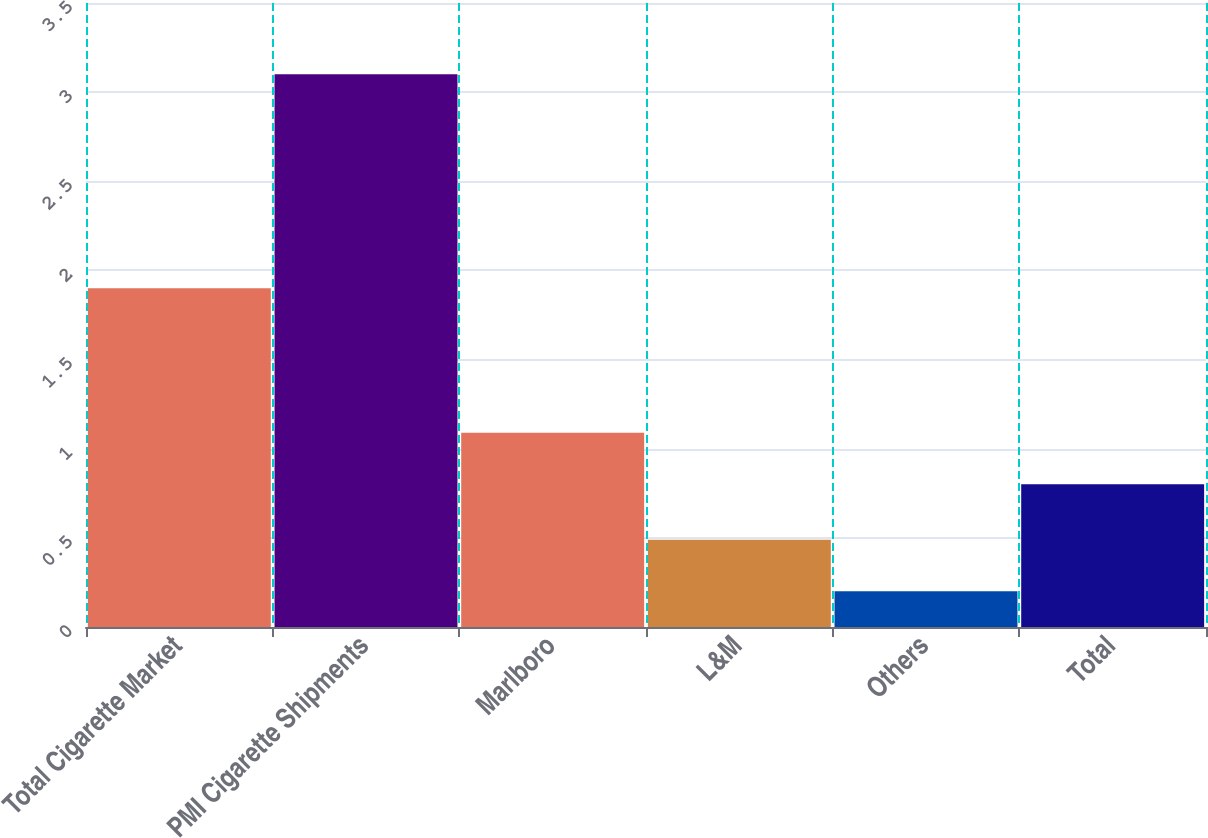Convert chart to OTSL. <chart><loc_0><loc_0><loc_500><loc_500><bar_chart><fcel>Total Cigarette Market<fcel>PMI Cigarette Shipments<fcel>Marlboro<fcel>L&M<fcel>Others<fcel>Total<nl><fcel>1.9<fcel>3.1<fcel>1.09<fcel>0.49<fcel>0.2<fcel>0.8<nl></chart> 